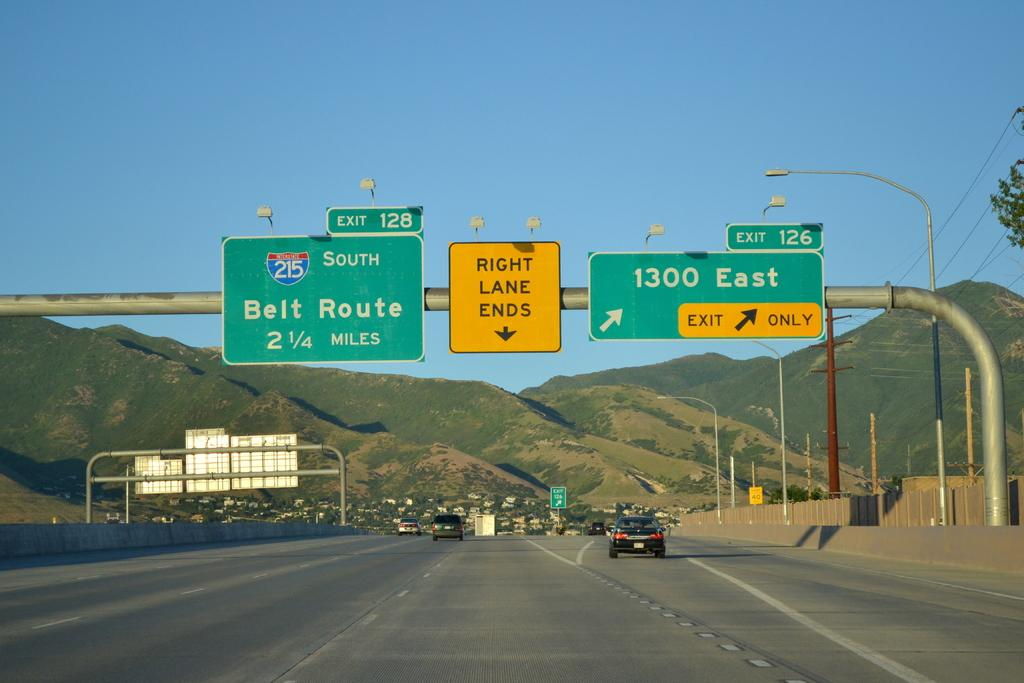<image>
Describe the image concisely. hifhway signs for exit 128 south to belt route or 1300 east exit 126 